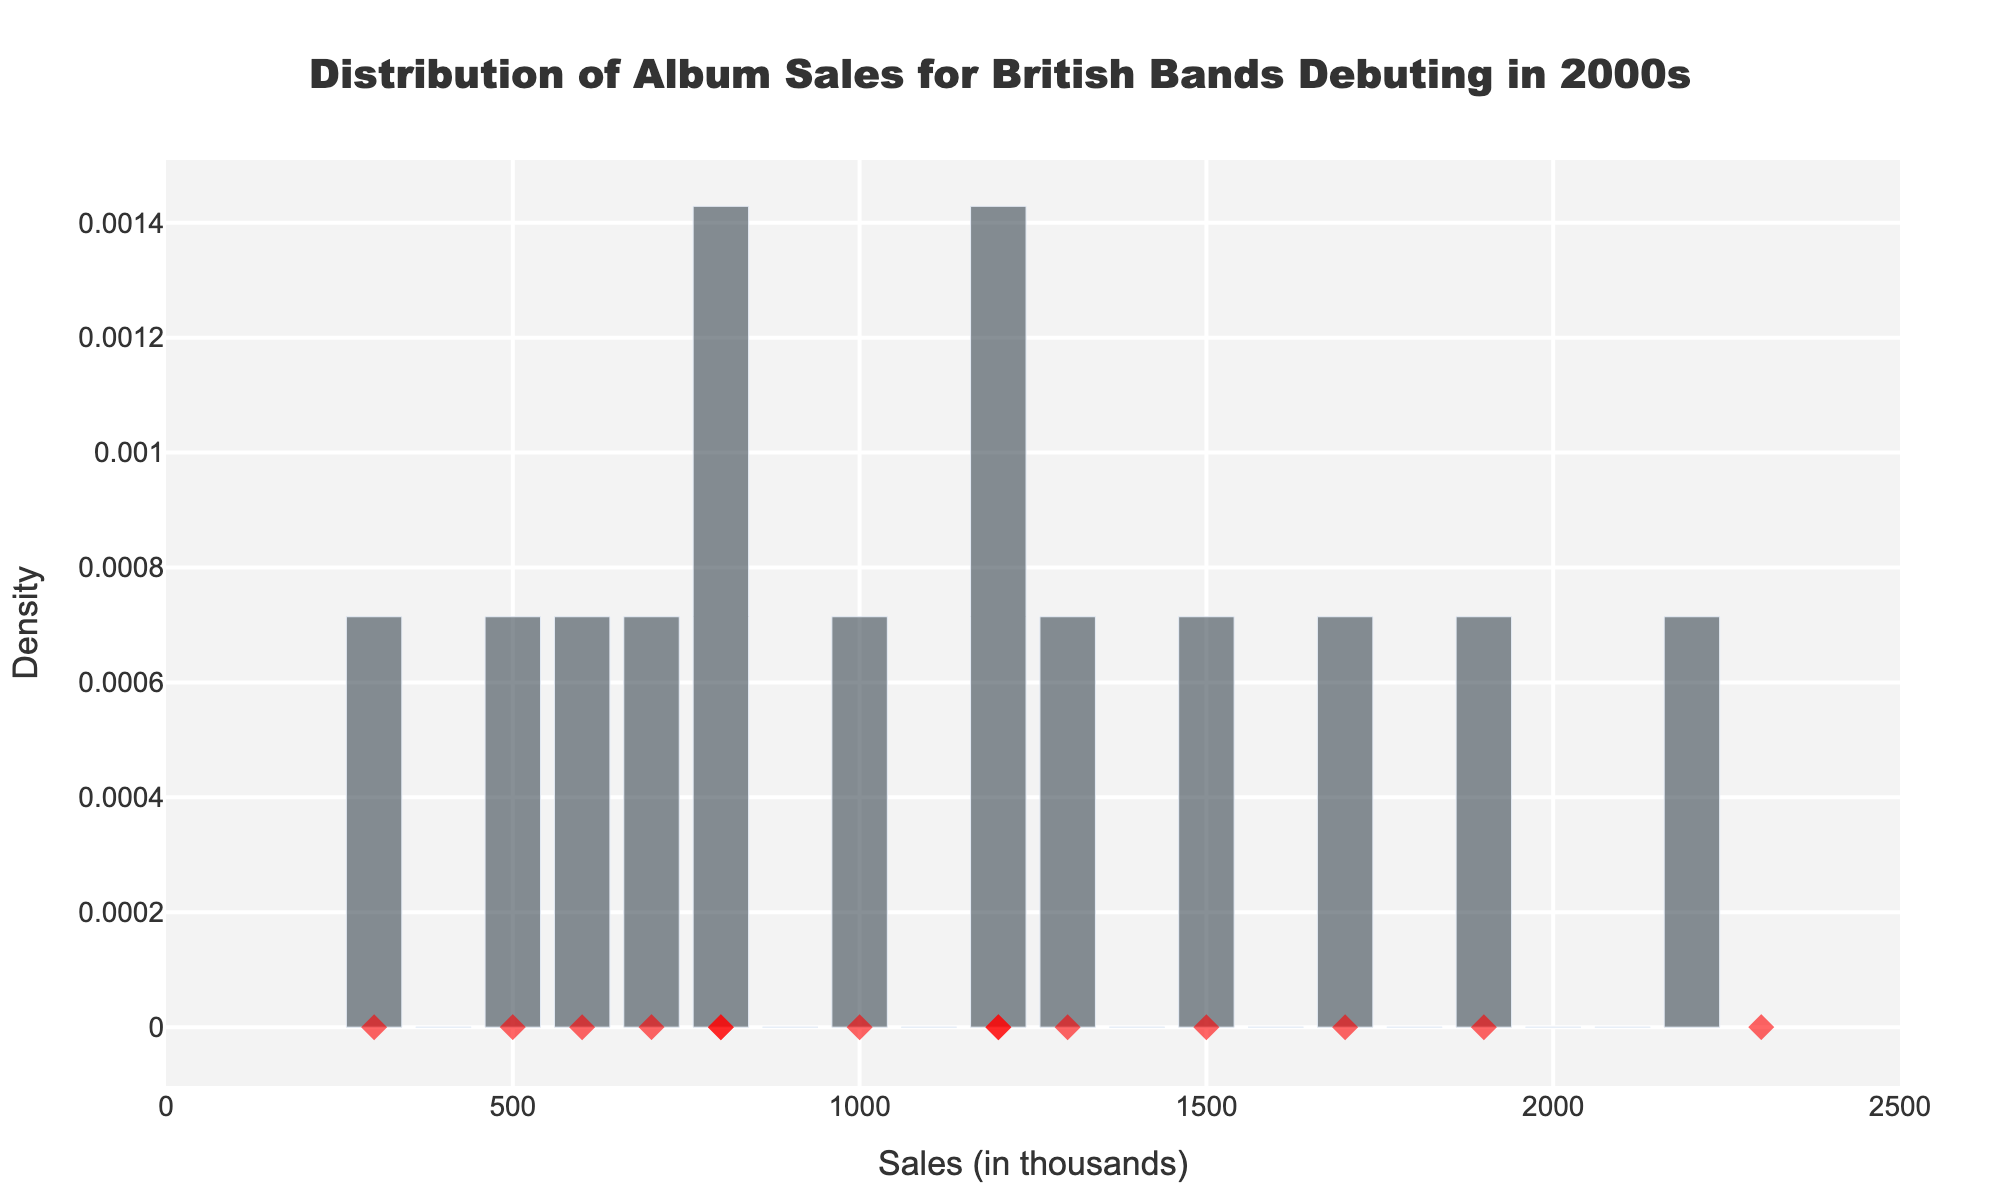What is the title of the chart? The title of the chart is displayed at the top and describes the content of the visual representation. It says "Distribution of Album Sales for British Bands Debuting in 2000s."
Answer: Distribution of Album Sales for British Bands Debuting in 2000s What is the range of the x-axis? The x-axis represents the sales figures in thousands, ranging from the smallest value at the left to the largest value at the right. The values on the x-axis range from 0 to 2500.
Answer: 0 to 2500 How many albums sold more than 1500 thousand units? To find the answer, look at the red diamond markers above the 1500 thousand value on the x-axis. These indicate the albums He sold more than 1500 thousand units. Three albums sold more than 1500 thousand units.
Answer: 3 What is the band with the highest album sales and how much did they sell? The red diamond marker farthest to the right represents the album with the highest sales. Hovering over it or checking its position shows it's "Hopes and Fears" by Keane, which sold 2300 thousand units.
Answer: Keane, 2300 thousand units Which bands have sales between 500 and 1000 thousand units? Look for red diamond markers positioned between 500 and 1000 on the x-axis and check their hover text or positions to identify the bands. The albums are "The Back Room" by Editors, "Stars of CCTV" by Hard-Fi, and "Razorlight" by Razorlight.
Answer: Editors, Hard-Fi, Razorlight What is the median album sales value from the dataset? To determine the median, list all sales values in ascending order and find the middle value. The sorted list of sales values is [300, 500, 600, 700, 800, 800, 1000, 1200, 1200, 1300, 1500, 1700, 1900, 2300]. The middle value is the 8th value in the sorted list, which is 1200.
Answer: 1200 How do The Hoosiers' album sales compare to other bands? Checking the red diamond markers for "The Trick to Life" and "The Illusion of Safety," they sold 1200 and 300 thousand units respectively. The first album is around the median, while the second is much lower than most. This shows varied success compared to other bands in the dataset.
Answer: One album is around the median, one much lower Which band has the lowest album sales, and how much did they sell? The lowest red diamond marker identifies the album with the lowest sales. Hovering over or checking its position shows it's "The Illusion of Safety" by The Hoosiers, which sold 300 thousand units.
Answer: The Hoosiers, 300 thousand units 